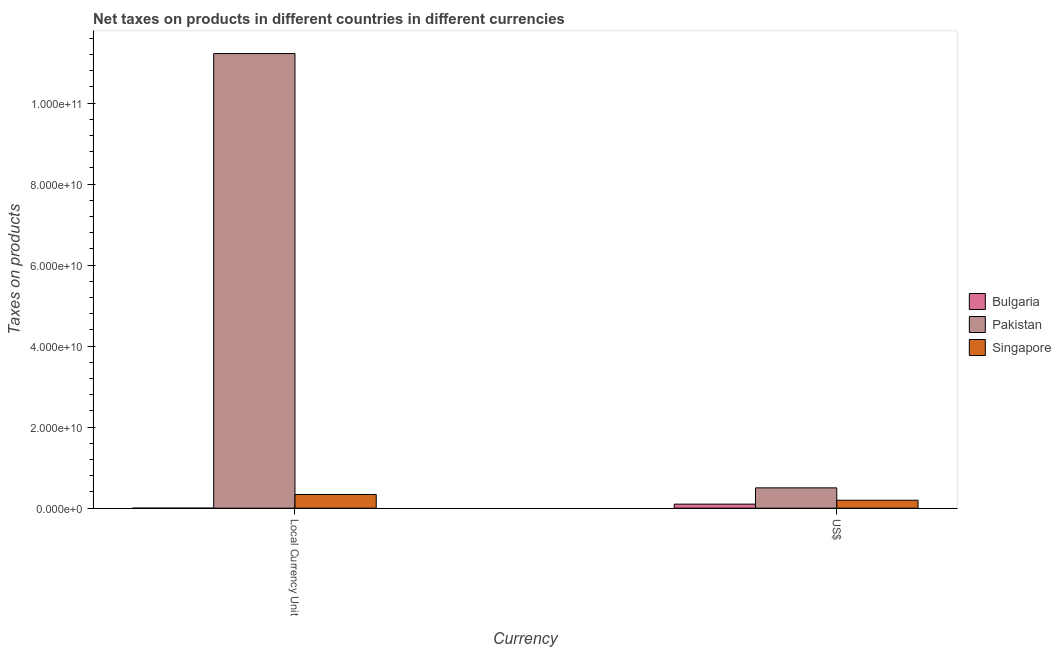Are the number of bars per tick equal to the number of legend labels?
Provide a succinct answer. Yes. Are the number of bars on each tick of the X-axis equal?
Your response must be concise. Yes. How many bars are there on the 1st tick from the left?
Offer a terse response. 3. How many bars are there on the 1st tick from the right?
Ensure brevity in your answer.  3. What is the label of the 2nd group of bars from the left?
Ensure brevity in your answer.  US$. What is the net taxes in constant 2005 us$ in Pakistan?
Offer a very short reply. 1.12e+11. Across all countries, what is the maximum net taxes in us$?
Ensure brevity in your answer.  5.02e+09. Across all countries, what is the minimum net taxes in constant 2005 us$?
Your response must be concise. 1.24e+07. What is the total net taxes in us$ in the graph?
Offer a terse response. 7.98e+09. What is the difference between the net taxes in us$ in Singapore and that in Pakistan?
Your answer should be compact. -3.06e+09. What is the difference between the net taxes in us$ in Bulgaria and the net taxes in constant 2005 us$ in Pakistan?
Offer a very short reply. -1.11e+11. What is the average net taxes in us$ per country?
Your answer should be compact. 2.66e+09. What is the difference between the net taxes in us$ and net taxes in constant 2005 us$ in Bulgaria?
Your answer should be compact. 9.91e+08. In how many countries, is the net taxes in constant 2005 us$ greater than 24000000000 units?
Your response must be concise. 1. What is the ratio of the net taxes in constant 2005 us$ in Bulgaria to that in Singapore?
Your answer should be very brief. 0. What is the difference between two consecutive major ticks on the Y-axis?
Provide a succinct answer. 2.00e+1. Does the graph contain any zero values?
Your response must be concise. No. Where does the legend appear in the graph?
Make the answer very short. Center right. How many legend labels are there?
Give a very brief answer. 3. How are the legend labels stacked?
Keep it short and to the point. Vertical. What is the title of the graph?
Offer a terse response. Net taxes on products in different countries in different currencies. Does "Sweden" appear as one of the legend labels in the graph?
Ensure brevity in your answer.  No. What is the label or title of the X-axis?
Give a very brief answer. Currency. What is the label or title of the Y-axis?
Your response must be concise. Taxes on products. What is the Taxes on products of Bulgaria in Local Currency Unit?
Ensure brevity in your answer.  1.24e+07. What is the Taxes on products of Pakistan in Local Currency Unit?
Make the answer very short. 1.12e+11. What is the Taxes on products in Singapore in Local Currency Unit?
Your answer should be compact. 3.39e+09. What is the Taxes on products in Bulgaria in US$?
Offer a very short reply. 1.00e+09. What is the Taxes on products in Pakistan in US$?
Your response must be concise. 5.02e+09. What is the Taxes on products in Singapore in US$?
Your answer should be compact. 1.96e+09. Across all Currency, what is the maximum Taxes on products in Bulgaria?
Your answer should be compact. 1.00e+09. Across all Currency, what is the maximum Taxes on products in Pakistan?
Offer a very short reply. 1.12e+11. Across all Currency, what is the maximum Taxes on products of Singapore?
Provide a short and direct response. 3.39e+09. Across all Currency, what is the minimum Taxes on products of Bulgaria?
Keep it short and to the point. 1.24e+07. Across all Currency, what is the minimum Taxes on products in Pakistan?
Make the answer very short. 5.02e+09. Across all Currency, what is the minimum Taxes on products of Singapore?
Your response must be concise. 1.96e+09. What is the total Taxes on products in Bulgaria in the graph?
Your response must be concise. 1.02e+09. What is the total Taxes on products in Pakistan in the graph?
Your answer should be very brief. 1.17e+11. What is the total Taxes on products in Singapore in the graph?
Give a very brief answer. 5.35e+09. What is the difference between the Taxes on products of Bulgaria in Local Currency Unit and that in US$?
Your answer should be compact. -9.91e+08. What is the difference between the Taxes on products of Pakistan in Local Currency Unit and that in US$?
Your answer should be compact. 1.07e+11. What is the difference between the Taxes on products in Singapore in Local Currency Unit and that in US$?
Offer a very short reply. 1.43e+09. What is the difference between the Taxes on products of Bulgaria in Local Currency Unit and the Taxes on products of Pakistan in US$?
Give a very brief answer. -5.00e+09. What is the difference between the Taxes on products of Bulgaria in Local Currency Unit and the Taxes on products of Singapore in US$?
Offer a very short reply. -1.95e+09. What is the difference between the Taxes on products of Pakistan in Local Currency Unit and the Taxes on products of Singapore in US$?
Your answer should be compact. 1.10e+11. What is the average Taxes on products of Bulgaria per Currency?
Provide a short and direct response. 5.08e+08. What is the average Taxes on products in Pakistan per Currency?
Your response must be concise. 5.86e+1. What is the average Taxes on products of Singapore per Currency?
Provide a succinct answer. 2.68e+09. What is the difference between the Taxes on products of Bulgaria and Taxes on products of Pakistan in Local Currency Unit?
Your answer should be compact. -1.12e+11. What is the difference between the Taxes on products of Bulgaria and Taxes on products of Singapore in Local Currency Unit?
Keep it short and to the point. -3.38e+09. What is the difference between the Taxes on products in Pakistan and Taxes on products in Singapore in Local Currency Unit?
Provide a succinct answer. 1.09e+11. What is the difference between the Taxes on products in Bulgaria and Taxes on products in Pakistan in US$?
Ensure brevity in your answer.  -4.01e+09. What is the difference between the Taxes on products in Bulgaria and Taxes on products in Singapore in US$?
Provide a short and direct response. -9.59e+08. What is the difference between the Taxes on products in Pakistan and Taxes on products in Singapore in US$?
Your response must be concise. 3.06e+09. What is the ratio of the Taxes on products in Bulgaria in Local Currency Unit to that in US$?
Offer a very short reply. 0.01. What is the ratio of the Taxes on products in Pakistan in Local Currency Unit to that in US$?
Offer a very short reply. 22.37. What is the ratio of the Taxes on products of Singapore in Local Currency Unit to that in US$?
Ensure brevity in your answer.  1.73. What is the difference between the highest and the second highest Taxes on products in Bulgaria?
Keep it short and to the point. 9.91e+08. What is the difference between the highest and the second highest Taxes on products of Pakistan?
Offer a very short reply. 1.07e+11. What is the difference between the highest and the second highest Taxes on products in Singapore?
Your response must be concise. 1.43e+09. What is the difference between the highest and the lowest Taxes on products in Bulgaria?
Your answer should be compact. 9.91e+08. What is the difference between the highest and the lowest Taxes on products in Pakistan?
Keep it short and to the point. 1.07e+11. What is the difference between the highest and the lowest Taxes on products in Singapore?
Give a very brief answer. 1.43e+09. 